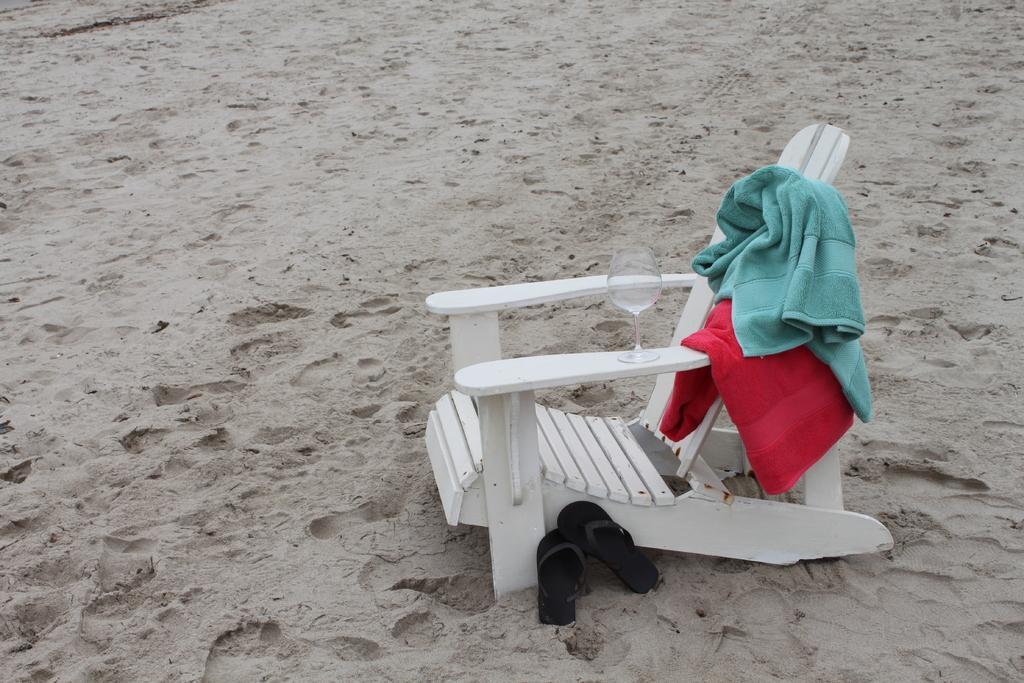In one or two sentences, can you explain what this image depicts? In this image I can see the white color chair. On the chair I can see two towels which are in green and red color. And there is a glass on it. I can also see the foot wear to the side. These are on the sand. 